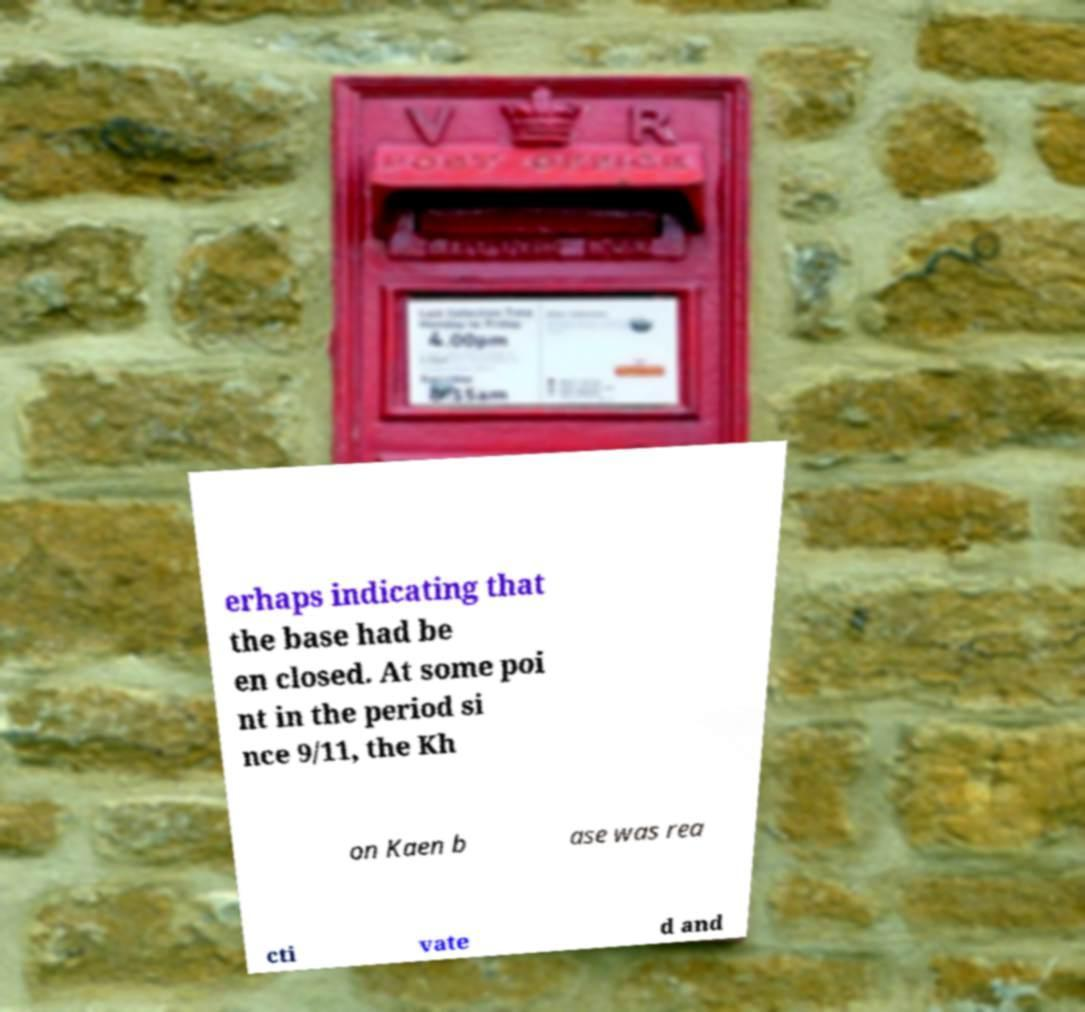Can you accurately transcribe the text from the provided image for me? erhaps indicating that the base had be en closed. At some poi nt in the period si nce 9/11, the Kh on Kaen b ase was rea cti vate d and 